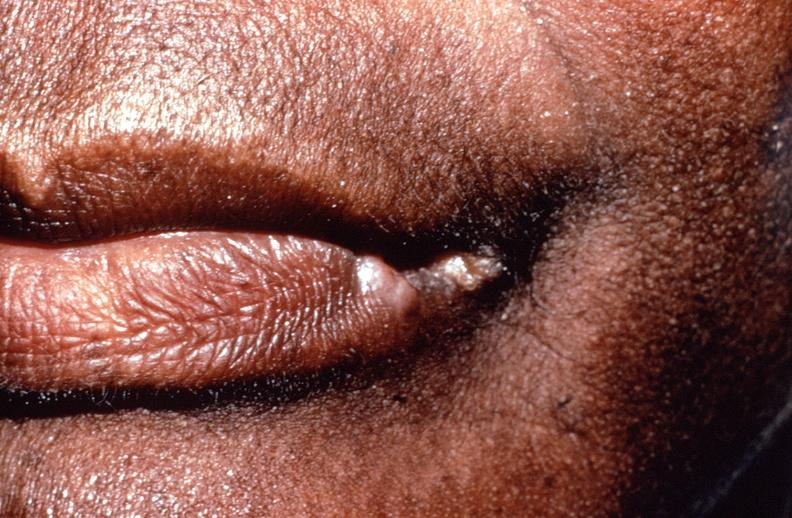what healed?
Answer the question using a single word or phrase. Squamous cell carcinoma, lip remote, 